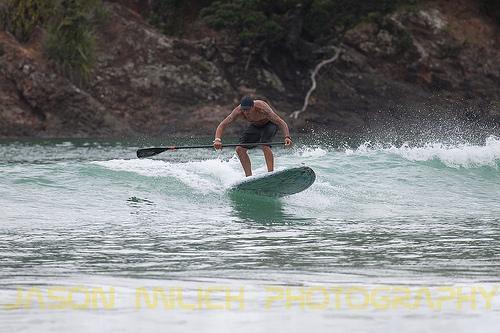How many of the wrists have a white band around them?
Give a very brief answer. 1. 